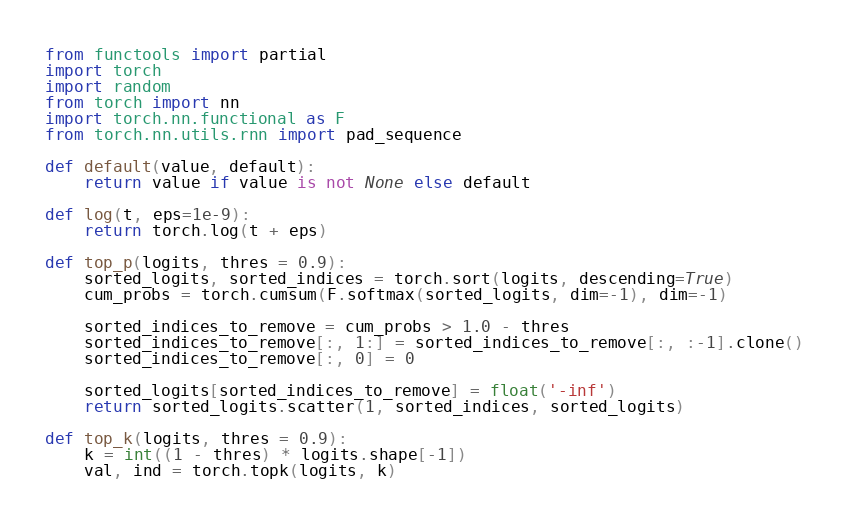Convert code to text. <code><loc_0><loc_0><loc_500><loc_500><_Python_>from functools import partial
import torch
import random
from torch import nn
import torch.nn.functional as F
from torch.nn.utils.rnn import pad_sequence

def default(value, default):
    return value if value is not None else default

def log(t, eps=1e-9):
    return torch.log(t + eps)

def top_p(logits, thres = 0.9):
    sorted_logits, sorted_indices = torch.sort(logits, descending=True)
    cum_probs = torch.cumsum(F.softmax(sorted_logits, dim=-1), dim=-1)

    sorted_indices_to_remove = cum_probs > 1.0 - thres
    sorted_indices_to_remove[:, 1:] = sorted_indices_to_remove[:, :-1].clone()
    sorted_indices_to_remove[:, 0] = 0

    sorted_logits[sorted_indices_to_remove] = float('-inf')
    return sorted_logits.scatter(1, sorted_indices, sorted_logits)

def top_k(logits, thres = 0.9):
    k = int((1 - thres) * logits.shape[-1])
    val, ind = torch.topk(logits, k)</code> 